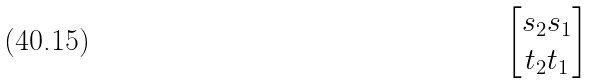Convert formula to latex. <formula><loc_0><loc_0><loc_500><loc_500>\begin{bmatrix} s _ { 2 } s _ { 1 } \\ t _ { 2 } t _ { 1 } \end{bmatrix}</formula> 